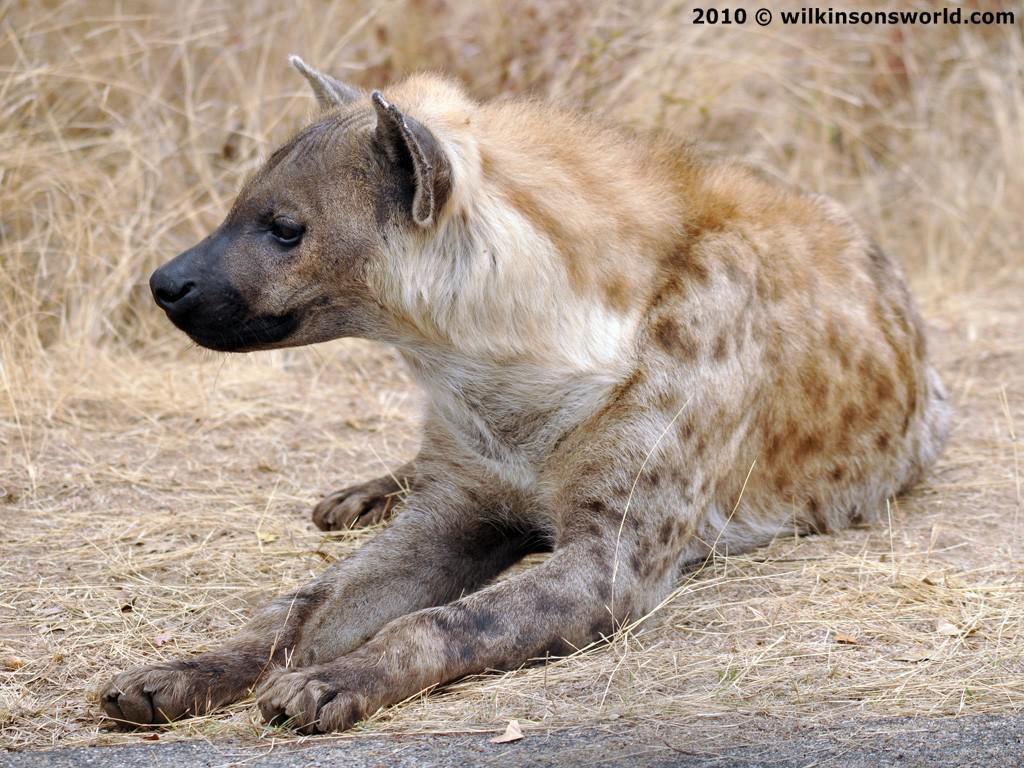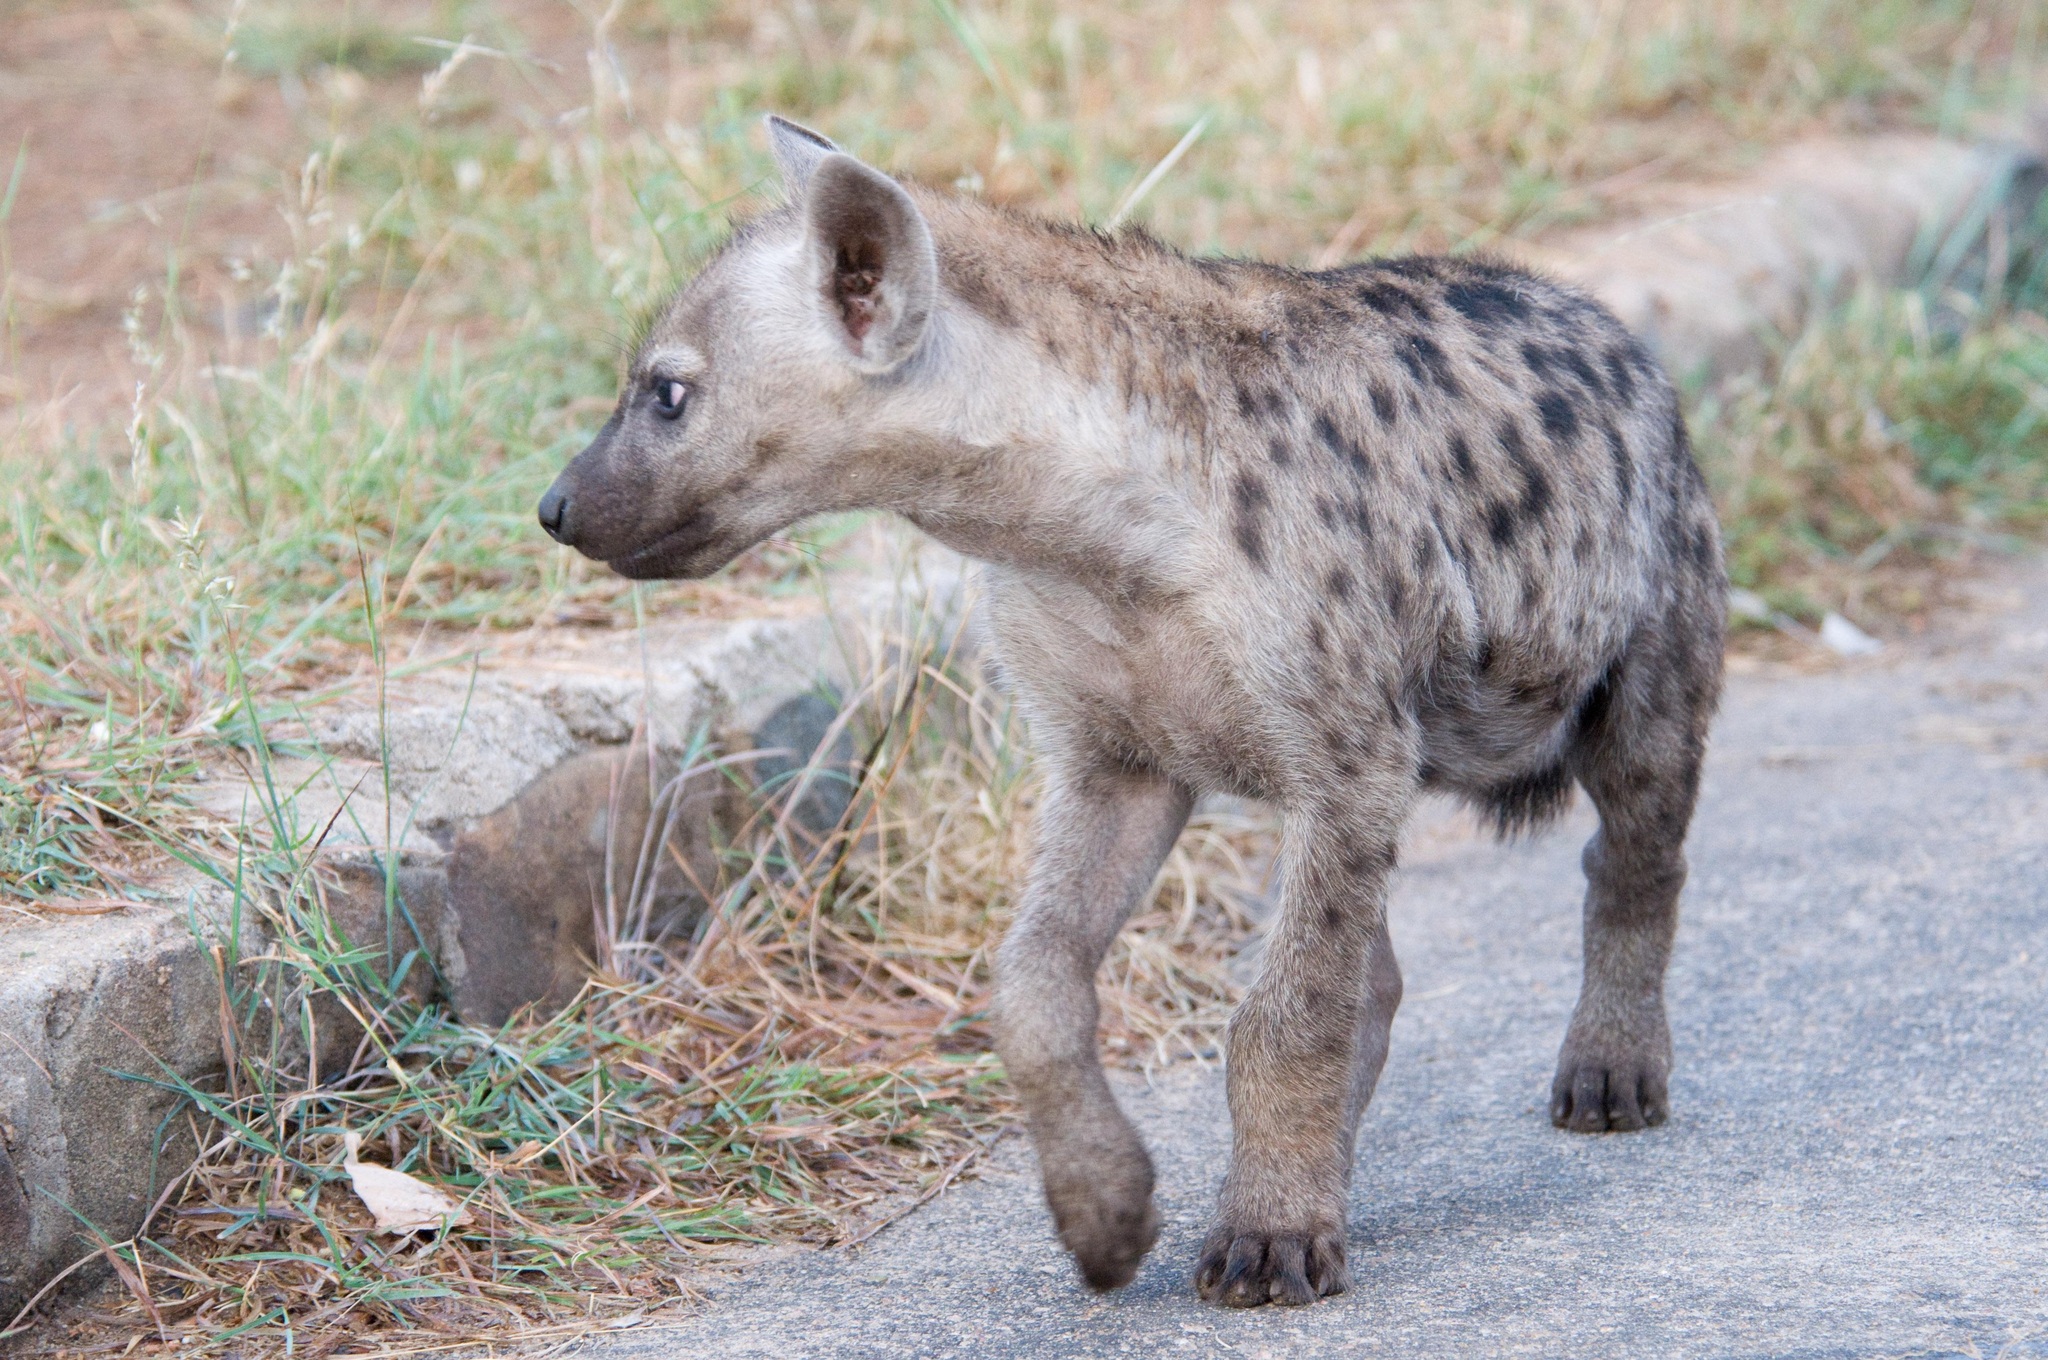The first image is the image on the left, the second image is the image on the right. Given the left and right images, does the statement "The animals in both pictures are facing left." hold true? Answer yes or no. Yes. The first image is the image on the left, the second image is the image on the right. Evaluate the accuracy of this statement regarding the images: "Each image contains exactly one hyena, and each hyena pictured has its head on the left of the image.". Is it true? Answer yes or no. Yes. 